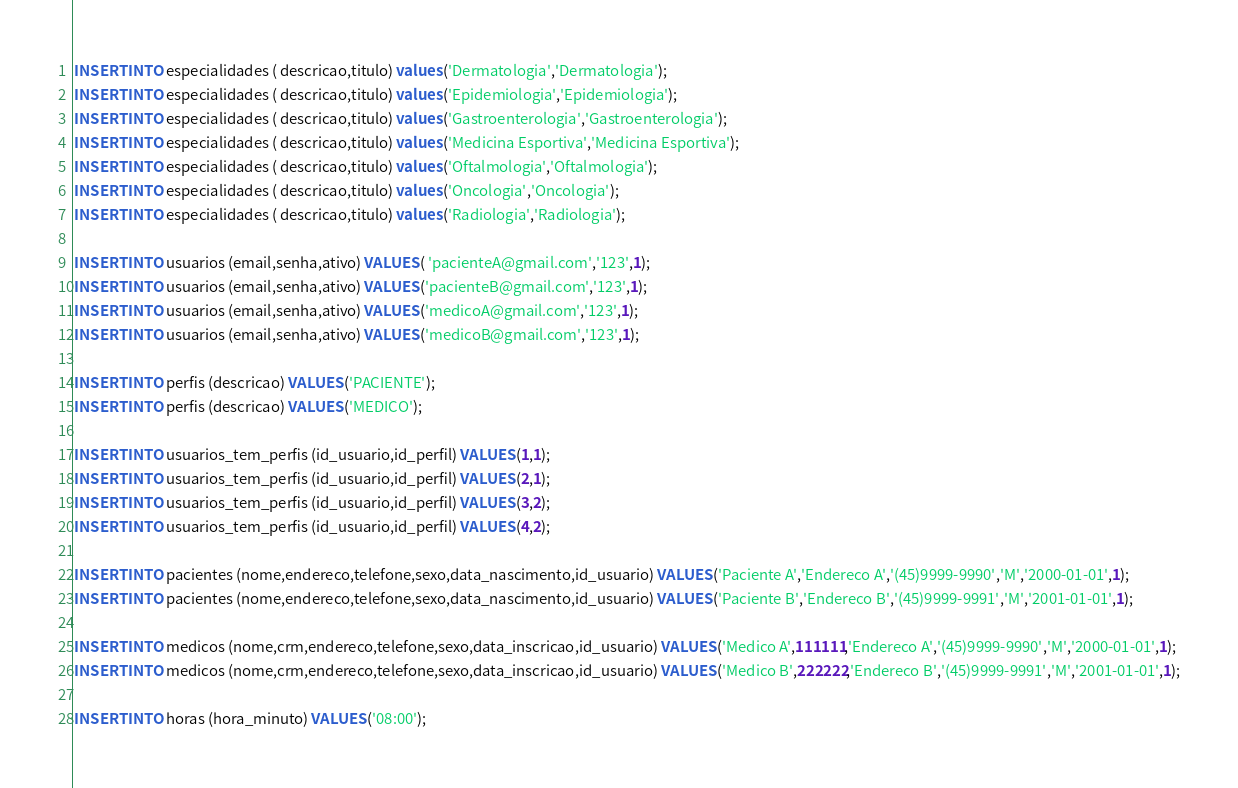<code> <loc_0><loc_0><loc_500><loc_500><_SQL_>
INSERT INTO especialidades ( descricao,titulo) values ('Dermatologia','Dermatologia');
INSERT INTO especialidades ( descricao,titulo) values ('Epidemiologia','Epidemiologia');
INSERT INTO especialidades ( descricao,titulo) values ('Gastroenterologia','Gastroenterologia');
INSERT INTO especialidades ( descricao,titulo) values ('Medicina Esportiva','Medicina Esportiva');
INSERT INTO especialidades ( descricao,titulo) values ('Oftalmologia','Oftalmologia');
INSERT INTO especialidades ( descricao,titulo) values ('Oncologia','Oncologia');
INSERT INTO especialidades ( descricao,titulo) values ('Radiologia','Radiologia');

INSERT INTO usuarios (email,senha,ativo) VALUES ( 'pacienteA@gmail.com','123',1);
INSERT INTO usuarios (email,senha,ativo) VALUES ('pacienteB@gmail.com','123',1);
INSERT INTO usuarios (email,senha,ativo) VALUES ('medicoA@gmail.com','123',1);
INSERT INTO usuarios (email,senha,ativo) VALUES ('medicoB@gmail.com','123',1);

INSERT INTO perfis (descricao) VALUES ('PACIENTE');
INSERT INTO perfis (descricao) VALUES ('MEDICO');

INSERT INTO usuarios_tem_perfis (id_usuario,id_perfil) VALUES (1,1);
INSERT INTO usuarios_tem_perfis (id_usuario,id_perfil) VALUES (2,1);
INSERT INTO usuarios_tem_perfis (id_usuario,id_perfil) VALUES (3,2);
INSERT INTO usuarios_tem_perfis (id_usuario,id_perfil) VALUES (4,2);

INSERT INTO pacientes (nome,endereco,telefone,sexo,data_nascimento,id_usuario) VALUES ('Paciente A','Endereco A','(45)9999-9990','M','2000-01-01',1);
INSERT INTO pacientes (nome,endereco,telefone,sexo,data_nascimento,id_usuario) VALUES ('Paciente B','Endereco B','(45)9999-9991','M','2001-01-01',1);

INSERT INTO medicos (nome,crm,endereco,telefone,sexo,data_inscricao,id_usuario) VALUES ('Medico A',111111,'Endereco A','(45)9999-9990','M','2000-01-01',1);
INSERT INTO medicos (nome,crm,endereco,telefone,sexo,data_inscricao,id_usuario) VALUES ('Medico B',222222,'Endereco B','(45)9999-9991','M','2001-01-01',1);

INSERT INTO horas (hora_minuto) VALUES ('08:00');</code> 